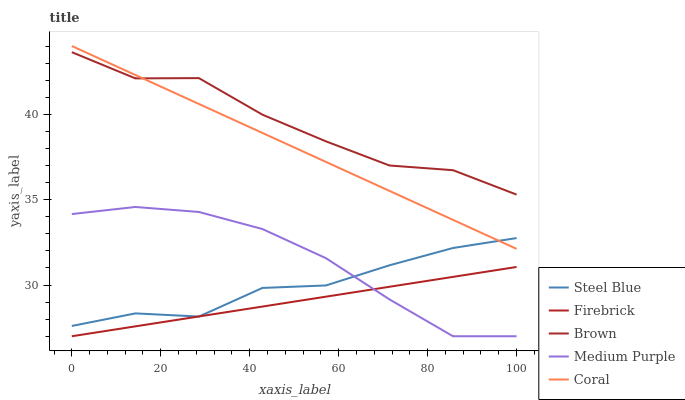Does Firebrick have the minimum area under the curve?
Answer yes or no. Yes. Does Brown have the maximum area under the curve?
Answer yes or no. Yes. Does Brown have the minimum area under the curve?
Answer yes or no. No. Does Firebrick have the maximum area under the curve?
Answer yes or no. No. Is Firebrick the smoothest?
Answer yes or no. Yes. Is Brown the roughest?
Answer yes or no. Yes. Is Brown the smoothest?
Answer yes or no. No. Is Firebrick the roughest?
Answer yes or no. No. Does Medium Purple have the lowest value?
Answer yes or no. Yes. Does Brown have the lowest value?
Answer yes or no. No. Does Coral have the highest value?
Answer yes or no. Yes. Does Brown have the highest value?
Answer yes or no. No. Is Firebrick less than Coral?
Answer yes or no. Yes. Is Coral greater than Medium Purple?
Answer yes or no. Yes. Does Steel Blue intersect Firebrick?
Answer yes or no. Yes. Is Steel Blue less than Firebrick?
Answer yes or no. No. Is Steel Blue greater than Firebrick?
Answer yes or no. No. Does Firebrick intersect Coral?
Answer yes or no. No. 